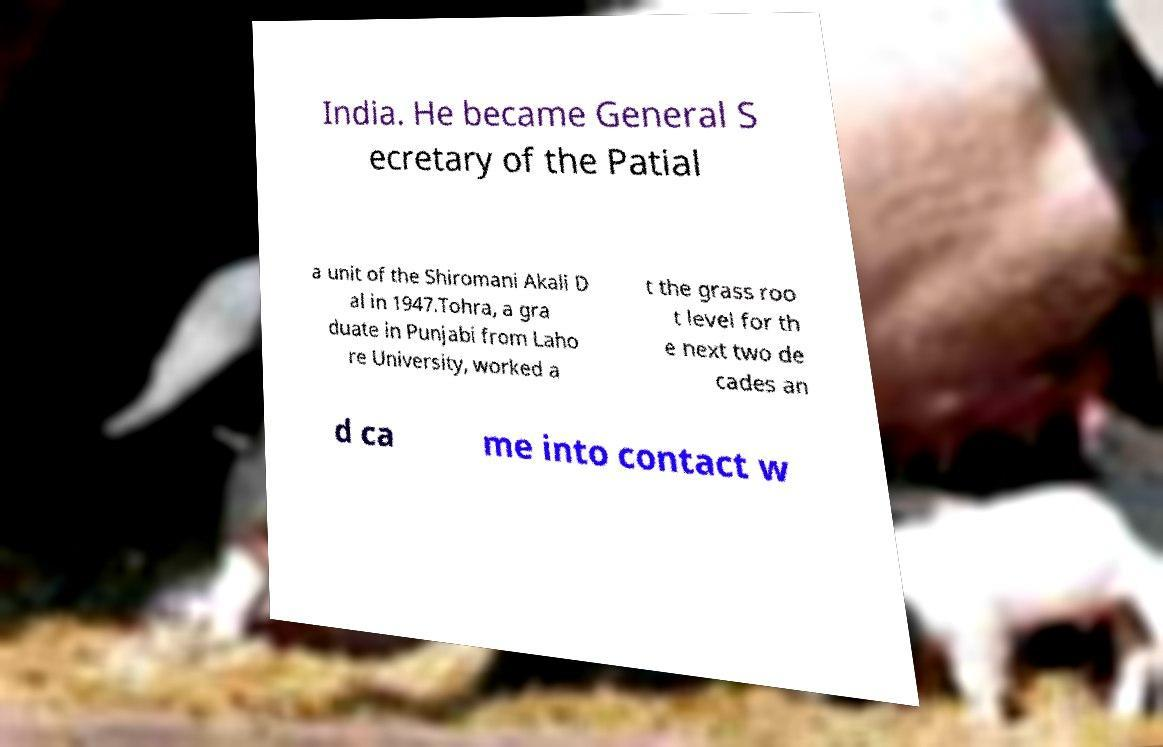Could you extract and type out the text from this image? India. He became General S ecretary of the Patial a unit of the Shiromani Akali D al in 1947.Tohra, a gra duate in Punjabi from Laho re University, worked a t the grass roo t level for th e next two de cades an d ca me into contact w 